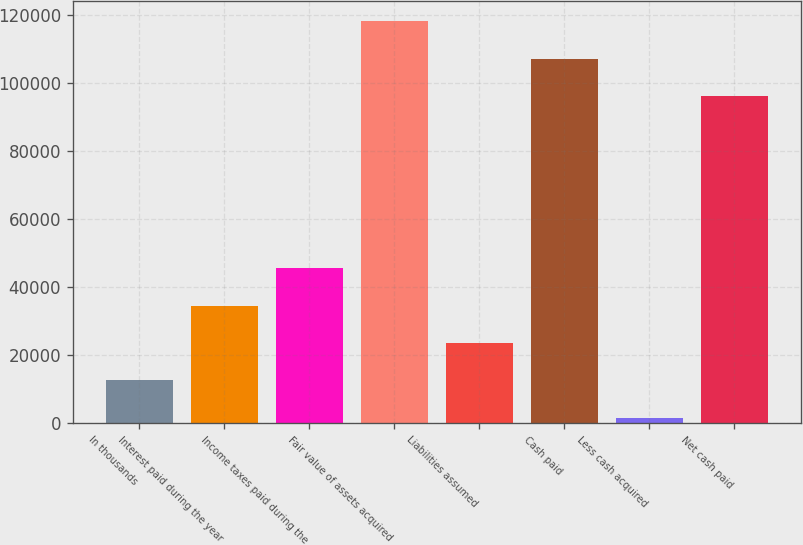Convert chart to OTSL. <chart><loc_0><loc_0><loc_500><loc_500><bar_chart><fcel>In thousands<fcel>Interest paid during the year<fcel>Income taxes paid during the<fcel>Fair value of assets acquired<fcel>Liabilities assumed<fcel>Cash paid<fcel>Less cash acquired<fcel>Net cash paid<nl><fcel>12544.3<fcel>34552.9<fcel>45557.2<fcel>118292<fcel>23548.6<fcel>107287<fcel>1540<fcel>96283<nl></chart> 